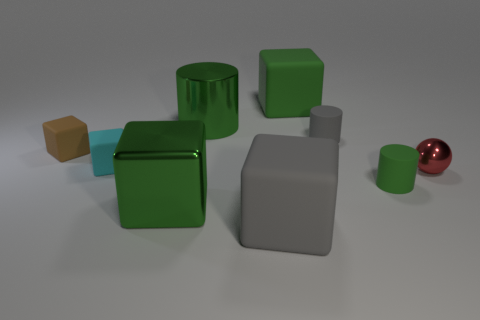The metallic object that is the same color as the large shiny cube is what shape?
Your answer should be very brief. Cylinder. What is the color of the tiny sphere?
Provide a short and direct response. Red. There is a cylinder that is the same size as the green metallic cube; what is its color?
Offer a very short reply. Green. The matte cylinder that is the same color as the metallic cylinder is what size?
Your response must be concise. Small. The red ball has what size?
Offer a very short reply. Small. There is a cyan thing; how many tiny cyan matte cubes are right of it?
Offer a very short reply. 0. There is a gray object behind the green metal thing in front of the red ball; what size is it?
Your answer should be very brief. Small. There is a metallic thing behind the tiny brown matte object; does it have the same shape as the big green object that is in front of the small cyan rubber block?
Offer a terse response. No. What is the shape of the green rubber object that is behind the shiny object that is on the right side of the green metal cylinder?
Offer a very short reply. Cube. What size is the green thing that is to the right of the large metal cylinder and in front of the big green matte thing?
Your answer should be very brief. Small. 